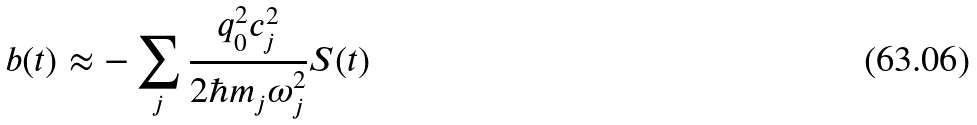<formula> <loc_0><loc_0><loc_500><loc_500>b ( t ) \approx - \sum _ { j } \frac { q ^ { 2 } _ { 0 } c ^ { 2 } _ { j } } { 2 \hbar { m } _ { j } \omega ^ { 2 } _ { j } } S ( t )</formula> 